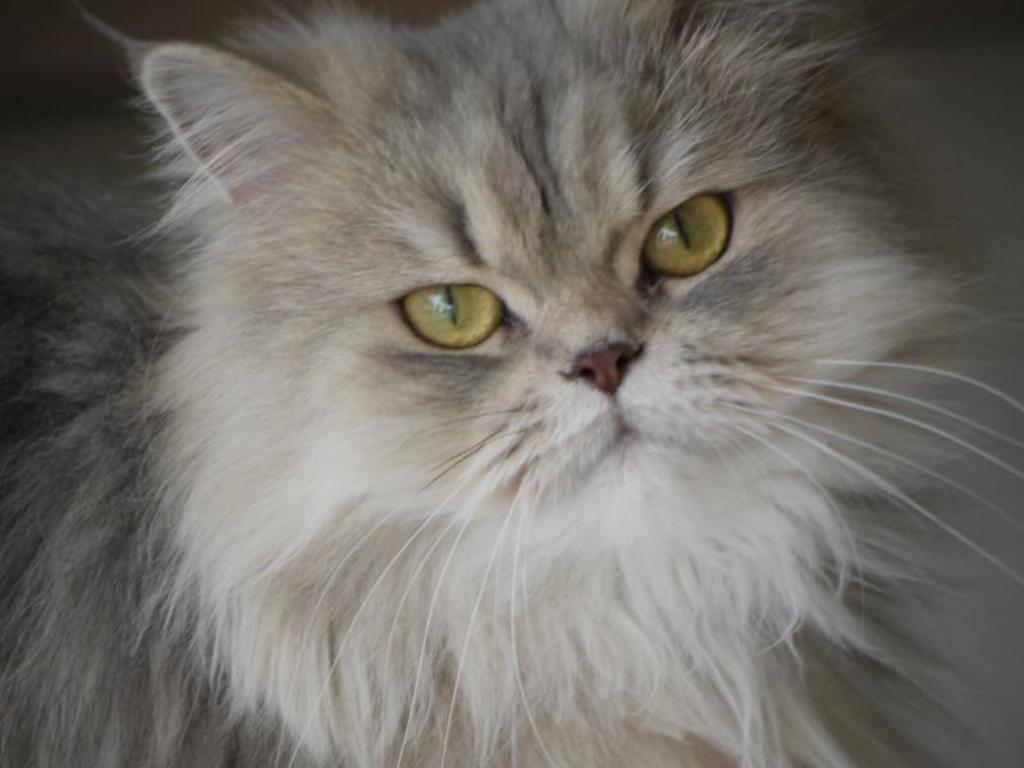What type of animal is in the picture? There is a cat in the picture. Can you describe the color of the cat? The cat is white and grey in color. What type of parent is the cat in the picture? The image does not show the cat as a parent, nor does it depict any parenting activities. 